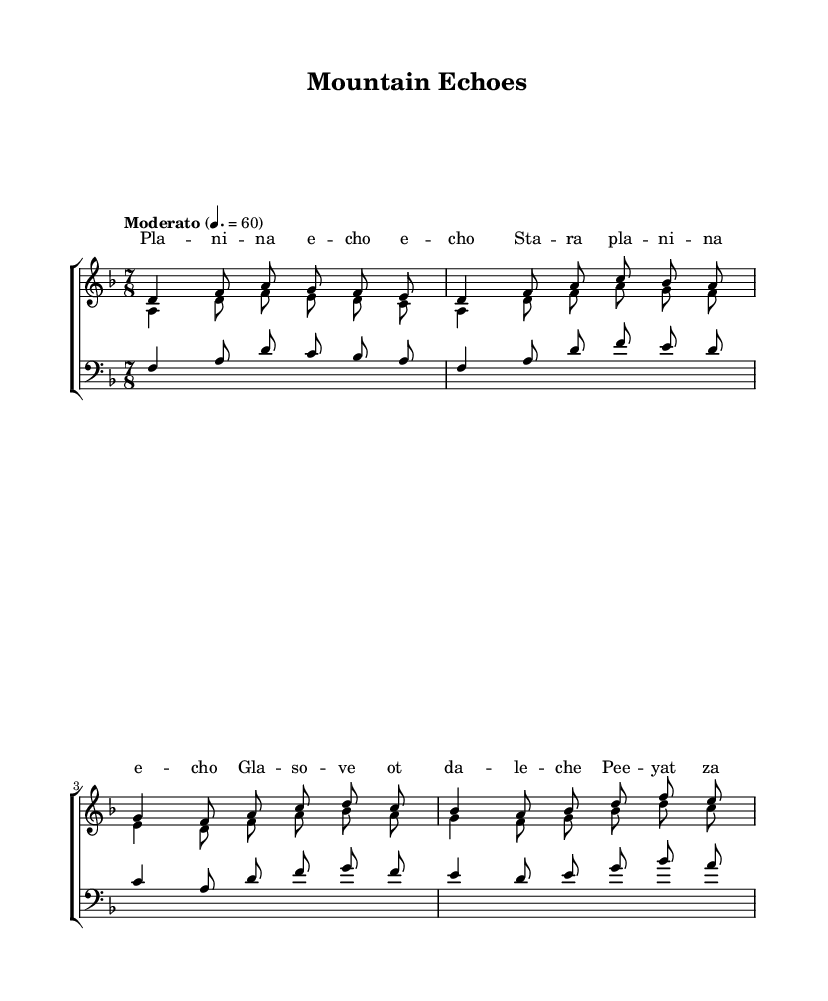What is the key signature of this music? The key signature is D minor, which has one flat note (B flat). This can be identified by looking at the left side of the staff where the key signature is notated.
Answer: D minor What is the time signature of this music? The time signature is 7/8. This can be determined by examining the fraction indicated at the beginning of the piece, which shows 7 beats in a measure and an eighth note receiving one beat.
Answer: 7/8 What is the tempo marking for this piece? The tempo marking is "Moderato" at quarter note equals 60. This is printed directly above the staff, indicating the intended speed of the music.
Answer: Moderato How many voices are in the choir? There are three voices in the choir: sopranos, altos, and tenors. This can be concluded by counting the distinct parts notated in the score, as each section is labeled accordingly.
Answer: Three What is the main harmonic structure used in this piece? The piece uses haunting a cappella harmonies, characterized by rich vocal textures that create a reverberating effect, typical of Bulgarian folk music. This is inferred from the notation and style typical of the genre.
Answer: A cappella harmonies Which traditional rhythm is likely present in this music? The rhythm is likely a compound meter, specifically related to the 7/8 time signature. This can be reasoned from the time signature indicating an irregular beat pattern, which aligns with traditional Bulgarian rhythms.
Answer: Compound meter 